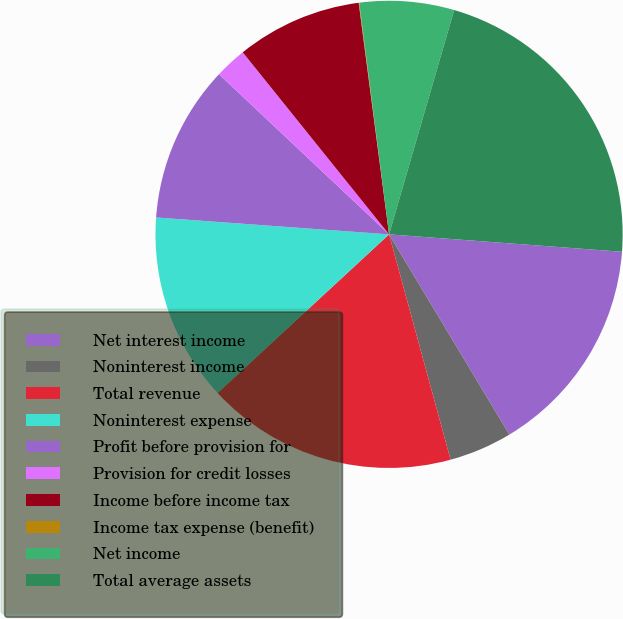<chart> <loc_0><loc_0><loc_500><loc_500><pie_chart><fcel>Net interest income<fcel>Noninterest income<fcel>Total revenue<fcel>Noninterest expense<fcel>Profit before provision for<fcel>Provision for credit losses<fcel>Income before income tax<fcel>Income tax expense (benefit)<fcel>Net income<fcel>Total average assets<nl><fcel>15.2%<fcel>4.37%<fcel>17.36%<fcel>13.03%<fcel>10.87%<fcel>2.2%<fcel>8.7%<fcel>0.04%<fcel>6.53%<fcel>21.69%<nl></chart> 